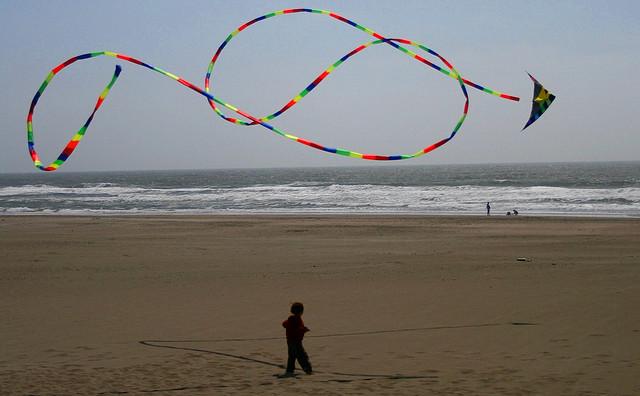What is the scene?
Be succinct. Beach. What is in the air?
Answer briefly. Kite. Is this a sandy beach?
Give a very brief answer. Yes. 